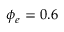<formula> <loc_0><loc_0><loc_500><loc_500>\phi _ { e } = 0 . 6</formula> 